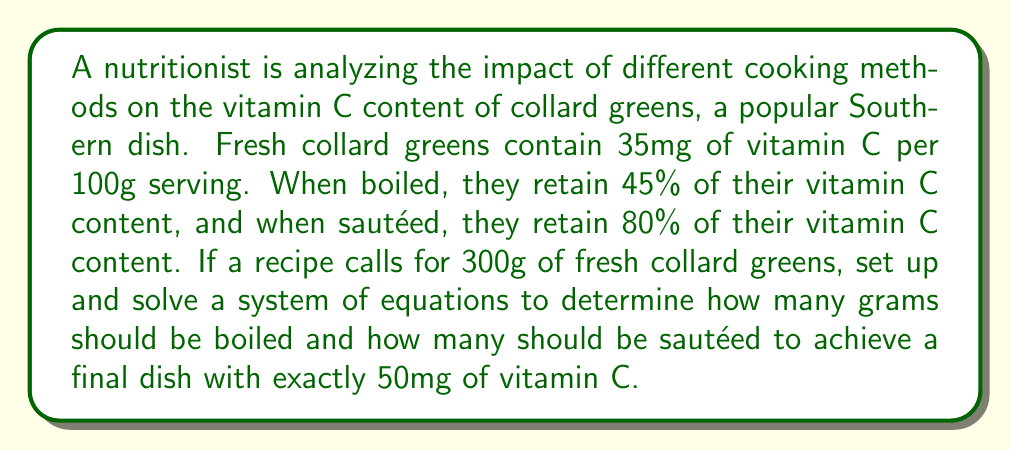Give your solution to this math problem. Let's approach this step-by-step:

1) Let $x$ be the grams of collard greens to be boiled and $y$ be the grams to be sautéed.

2) We know that the total amount of collard greens should be 300g:

   $$x + y = 300$$ (Equation 1)

3) Now, let's consider the vitamin C content:
   - Fresh collard greens have 35mg per 100g, so 0.35mg per gram
   - Boiled greens retain 45% of vitamin C: $0.35 \times 0.45 = 0.1575$mg per gram
   - Sautéed greens retain 80% of vitamin C: $0.35 \times 0.80 = 0.28$mg per gram

4) The total vitamin C content should be 50mg:

   $$0.1575x + 0.28y = 50$$ (Equation 2)

5) Now we have a system of two equations with two unknowns:

   $$\begin{cases}
   x + y = 300 \\
   0.1575x + 0.28y = 50
   \end{cases}$$

6) Let's solve this system by substitution. From Equation 1:
   
   $$y = 300 - x$$

7) Substitute this into Equation 2:

   $$0.1575x + 0.28(300 - x) = 50$$

8) Simplify:

   $$0.1575x + 84 - 0.28x = 50$$
   $$-0.1225x = -34$$
   $$x = 277.55$$

9) Substitute this back into Equation 1:

   $$y = 300 - 277.55 = 22.45$$

10) Therefore, approximately 277.55g should be boiled and 22.45g should be sautéed.
Answer: Boil 277.55g, sauté 22.45g 